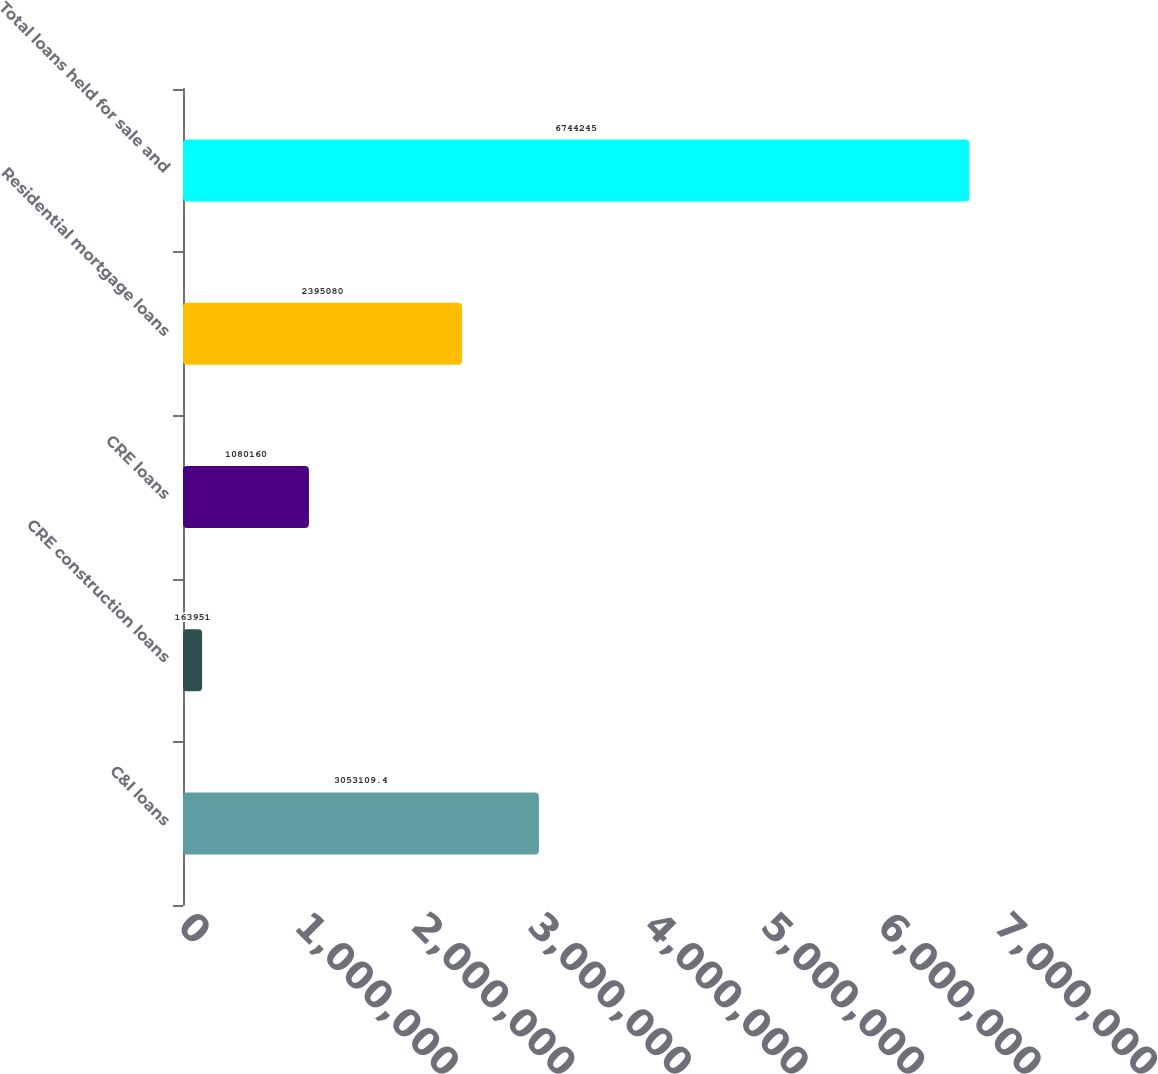<chart> <loc_0><loc_0><loc_500><loc_500><bar_chart><fcel>C&I loans<fcel>CRE construction loans<fcel>CRE loans<fcel>Residential mortgage loans<fcel>Total loans held for sale and<nl><fcel>3.05311e+06<fcel>163951<fcel>1.08016e+06<fcel>2.39508e+06<fcel>6.74424e+06<nl></chart> 